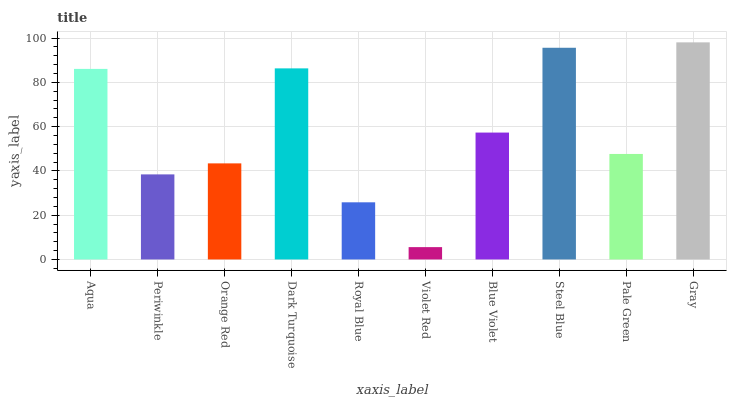Is Violet Red the minimum?
Answer yes or no. Yes. Is Gray the maximum?
Answer yes or no. Yes. Is Periwinkle the minimum?
Answer yes or no. No. Is Periwinkle the maximum?
Answer yes or no. No. Is Aqua greater than Periwinkle?
Answer yes or no. Yes. Is Periwinkle less than Aqua?
Answer yes or no. Yes. Is Periwinkle greater than Aqua?
Answer yes or no. No. Is Aqua less than Periwinkle?
Answer yes or no. No. Is Blue Violet the high median?
Answer yes or no. Yes. Is Pale Green the low median?
Answer yes or no. Yes. Is Dark Turquoise the high median?
Answer yes or no. No. Is Orange Red the low median?
Answer yes or no. No. 